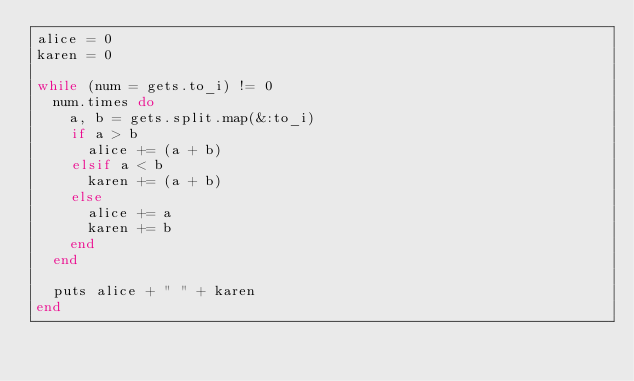Convert code to text. <code><loc_0><loc_0><loc_500><loc_500><_Ruby_>alice = 0
karen = 0

while (num = gets.to_i) != 0
  num.times do
    a, b = gets.split.map(&:to_i)
    if a > b
      alice += (a + b)
    elsif a < b
      karen += (a + b)
    else
      alice += a
      karen += b
    end
  end

  puts alice + " " + karen
end</code> 